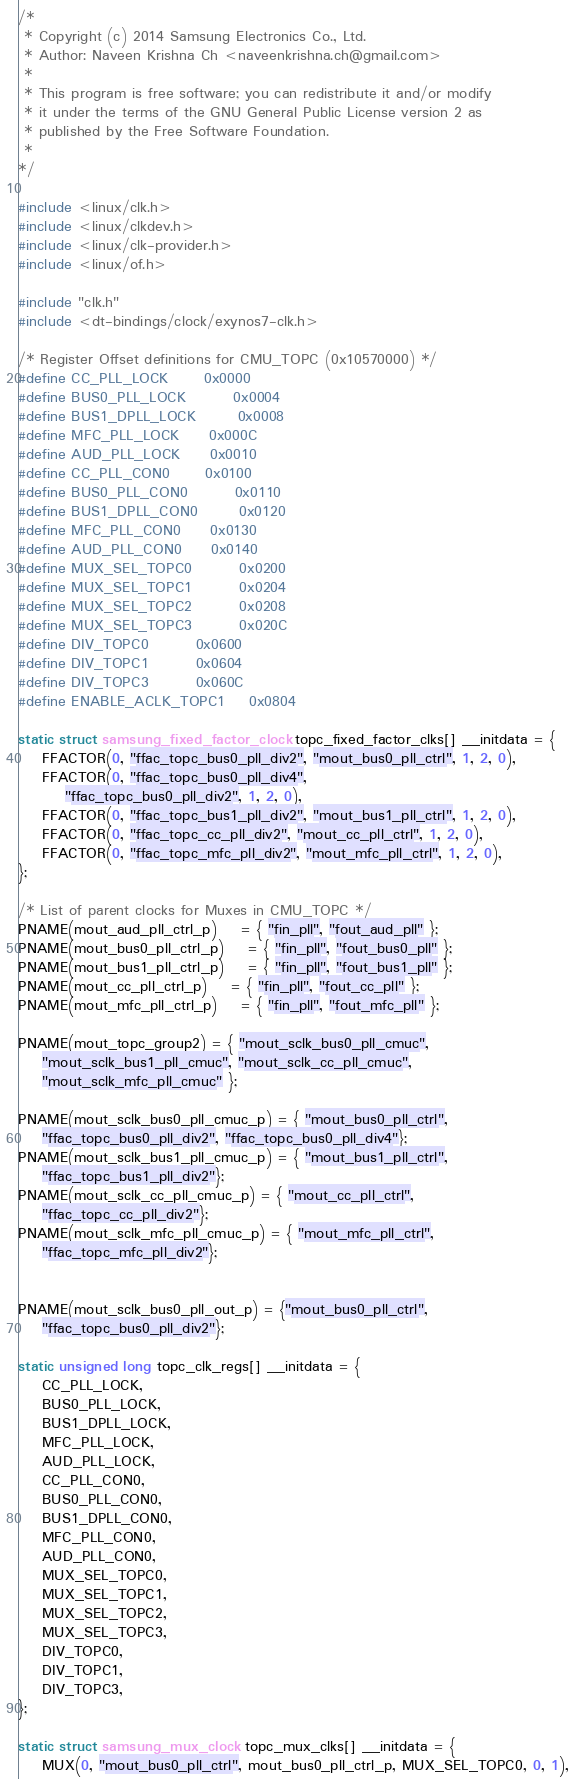Convert code to text. <code><loc_0><loc_0><loc_500><loc_500><_C_>/*
 * Copyright (c) 2014 Samsung Electronics Co., Ltd.
 * Author: Naveen Krishna Ch <naveenkrishna.ch@gmail.com>
 *
 * This program is free software; you can redistribute it and/or modify
 * it under the terms of the GNU General Public License version 2 as
 * published by the Free Software Foundation.
 *
*/

#include <linux/clk.h>
#include <linux/clkdev.h>
#include <linux/clk-provider.h>
#include <linux/of.h>

#include "clk.h"
#include <dt-bindings/clock/exynos7-clk.h>

/* Register Offset definitions for CMU_TOPC (0x10570000) */
#define CC_PLL_LOCK		0x0000
#define BUS0_PLL_LOCK		0x0004
#define BUS1_DPLL_LOCK		0x0008
#define MFC_PLL_LOCK		0x000C
#define AUD_PLL_LOCK		0x0010
#define CC_PLL_CON0		0x0100
#define BUS0_PLL_CON0		0x0110
#define BUS1_DPLL_CON0		0x0120
#define MFC_PLL_CON0		0x0130
#define AUD_PLL_CON0		0x0140
#define MUX_SEL_TOPC0		0x0200
#define MUX_SEL_TOPC1		0x0204
#define MUX_SEL_TOPC2		0x0208
#define MUX_SEL_TOPC3		0x020C
#define DIV_TOPC0		0x0600
#define DIV_TOPC1		0x0604
#define DIV_TOPC3		0x060C
#define ENABLE_ACLK_TOPC1	0x0804

static struct samsung_fixed_factor_clock topc_fixed_factor_clks[] __initdata = {
	FFACTOR(0, "ffac_topc_bus0_pll_div2", "mout_bus0_pll_ctrl", 1, 2, 0),
	FFACTOR(0, "ffac_topc_bus0_pll_div4",
		"ffac_topc_bus0_pll_div2", 1, 2, 0),
	FFACTOR(0, "ffac_topc_bus1_pll_div2", "mout_bus1_pll_ctrl", 1, 2, 0),
	FFACTOR(0, "ffac_topc_cc_pll_div2", "mout_cc_pll_ctrl", 1, 2, 0),
	FFACTOR(0, "ffac_topc_mfc_pll_div2", "mout_mfc_pll_ctrl", 1, 2, 0),
};

/* List of parent clocks for Muxes in CMU_TOPC */
PNAME(mout_aud_pll_ctrl_p)	= { "fin_pll", "fout_aud_pll" };
PNAME(mout_bus0_pll_ctrl_p)	= { "fin_pll", "fout_bus0_pll" };
PNAME(mout_bus1_pll_ctrl_p)	= { "fin_pll", "fout_bus1_pll" };
PNAME(mout_cc_pll_ctrl_p)	= { "fin_pll", "fout_cc_pll" };
PNAME(mout_mfc_pll_ctrl_p)	= { "fin_pll", "fout_mfc_pll" };

PNAME(mout_topc_group2) = { "mout_sclk_bus0_pll_cmuc",
	"mout_sclk_bus1_pll_cmuc", "mout_sclk_cc_pll_cmuc",
	"mout_sclk_mfc_pll_cmuc" };

PNAME(mout_sclk_bus0_pll_cmuc_p) = { "mout_bus0_pll_ctrl",
	"ffac_topc_bus0_pll_div2", "ffac_topc_bus0_pll_div4"};
PNAME(mout_sclk_bus1_pll_cmuc_p) = { "mout_bus1_pll_ctrl",
	"ffac_topc_bus1_pll_div2"};
PNAME(mout_sclk_cc_pll_cmuc_p) = { "mout_cc_pll_ctrl",
	"ffac_topc_cc_pll_div2"};
PNAME(mout_sclk_mfc_pll_cmuc_p) = { "mout_mfc_pll_ctrl",
	"ffac_topc_mfc_pll_div2"};


PNAME(mout_sclk_bus0_pll_out_p) = {"mout_bus0_pll_ctrl",
	"ffac_topc_bus0_pll_div2"};

static unsigned long topc_clk_regs[] __initdata = {
	CC_PLL_LOCK,
	BUS0_PLL_LOCK,
	BUS1_DPLL_LOCK,
	MFC_PLL_LOCK,
	AUD_PLL_LOCK,
	CC_PLL_CON0,
	BUS0_PLL_CON0,
	BUS1_DPLL_CON0,
	MFC_PLL_CON0,
	AUD_PLL_CON0,
	MUX_SEL_TOPC0,
	MUX_SEL_TOPC1,
	MUX_SEL_TOPC2,
	MUX_SEL_TOPC3,
	DIV_TOPC0,
	DIV_TOPC1,
	DIV_TOPC3,
};

static struct samsung_mux_clock topc_mux_clks[] __initdata = {
	MUX(0, "mout_bus0_pll_ctrl", mout_bus0_pll_ctrl_p, MUX_SEL_TOPC0, 0, 1),</code> 